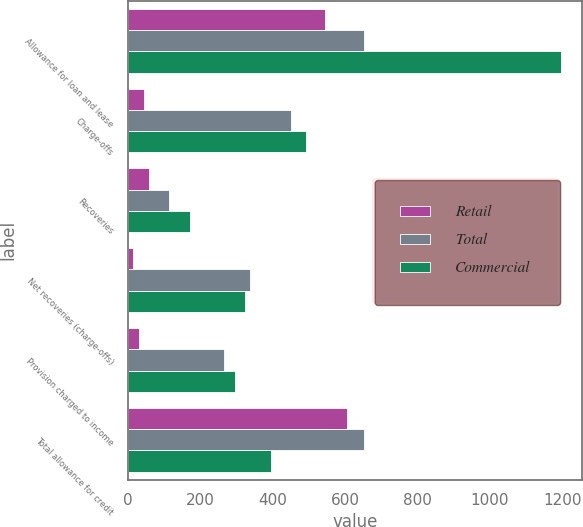Convert chart. <chart><loc_0><loc_0><loc_500><loc_500><stacked_bar_chart><ecel><fcel>Allowance for loan and lease<fcel>Charge-offs<fcel>Recoveries<fcel>Net recoveries (charge-offs)<fcel>Provision charged to income<fcel>Total allowance for credit<nl><fcel>Retail<fcel>544<fcel>43<fcel>58<fcel>15<fcel>31<fcel>605<nl><fcel>Total<fcel>651<fcel>450<fcel>112<fcel>338<fcel>266<fcel>651<nl><fcel>Commercial<fcel>1195<fcel>493<fcel>170<fcel>323<fcel>297<fcel>394<nl></chart> 